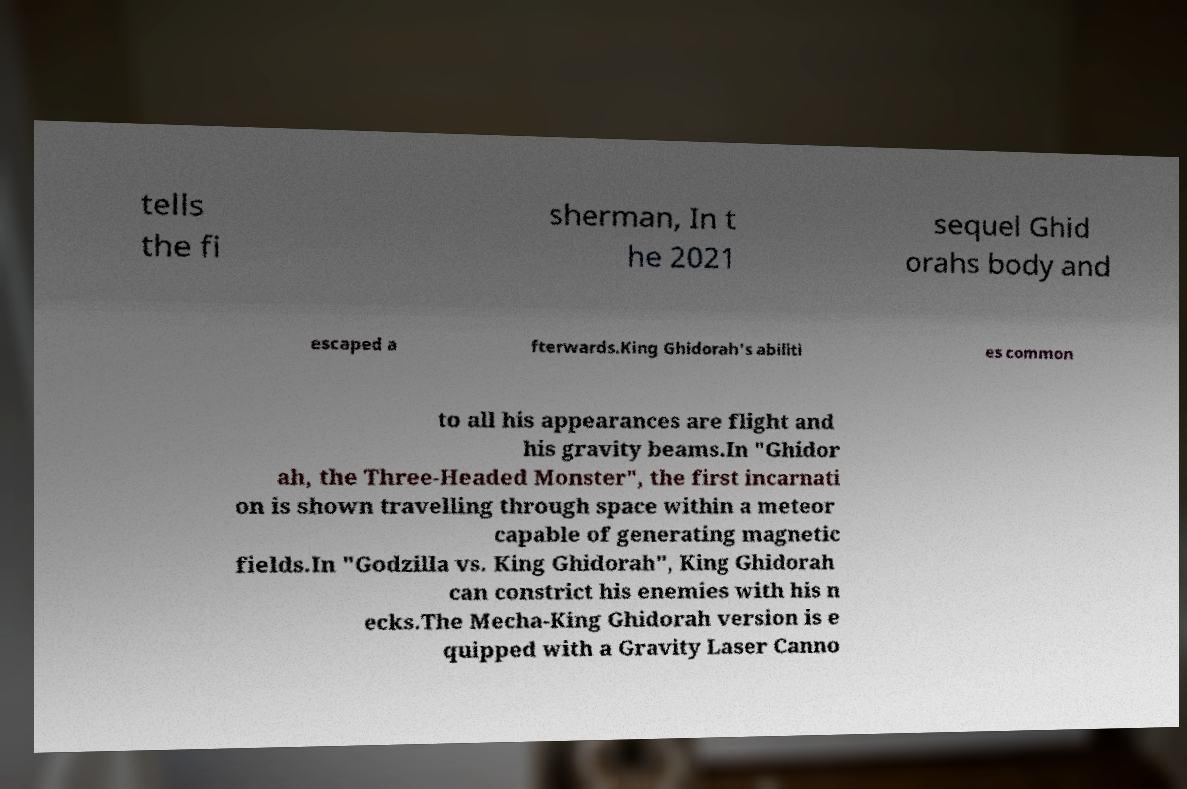For documentation purposes, I need the text within this image transcribed. Could you provide that? tells the fi sherman, In t he 2021 sequel Ghid orahs body and escaped a fterwards.King Ghidorah's abiliti es common to all his appearances are flight and his gravity beams.In "Ghidor ah, the Three-Headed Monster", the first incarnati on is shown travelling through space within a meteor capable of generating magnetic fields.In "Godzilla vs. King Ghidorah", King Ghidorah can constrict his enemies with his n ecks.The Mecha-King Ghidorah version is e quipped with a Gravity Laser Canno 